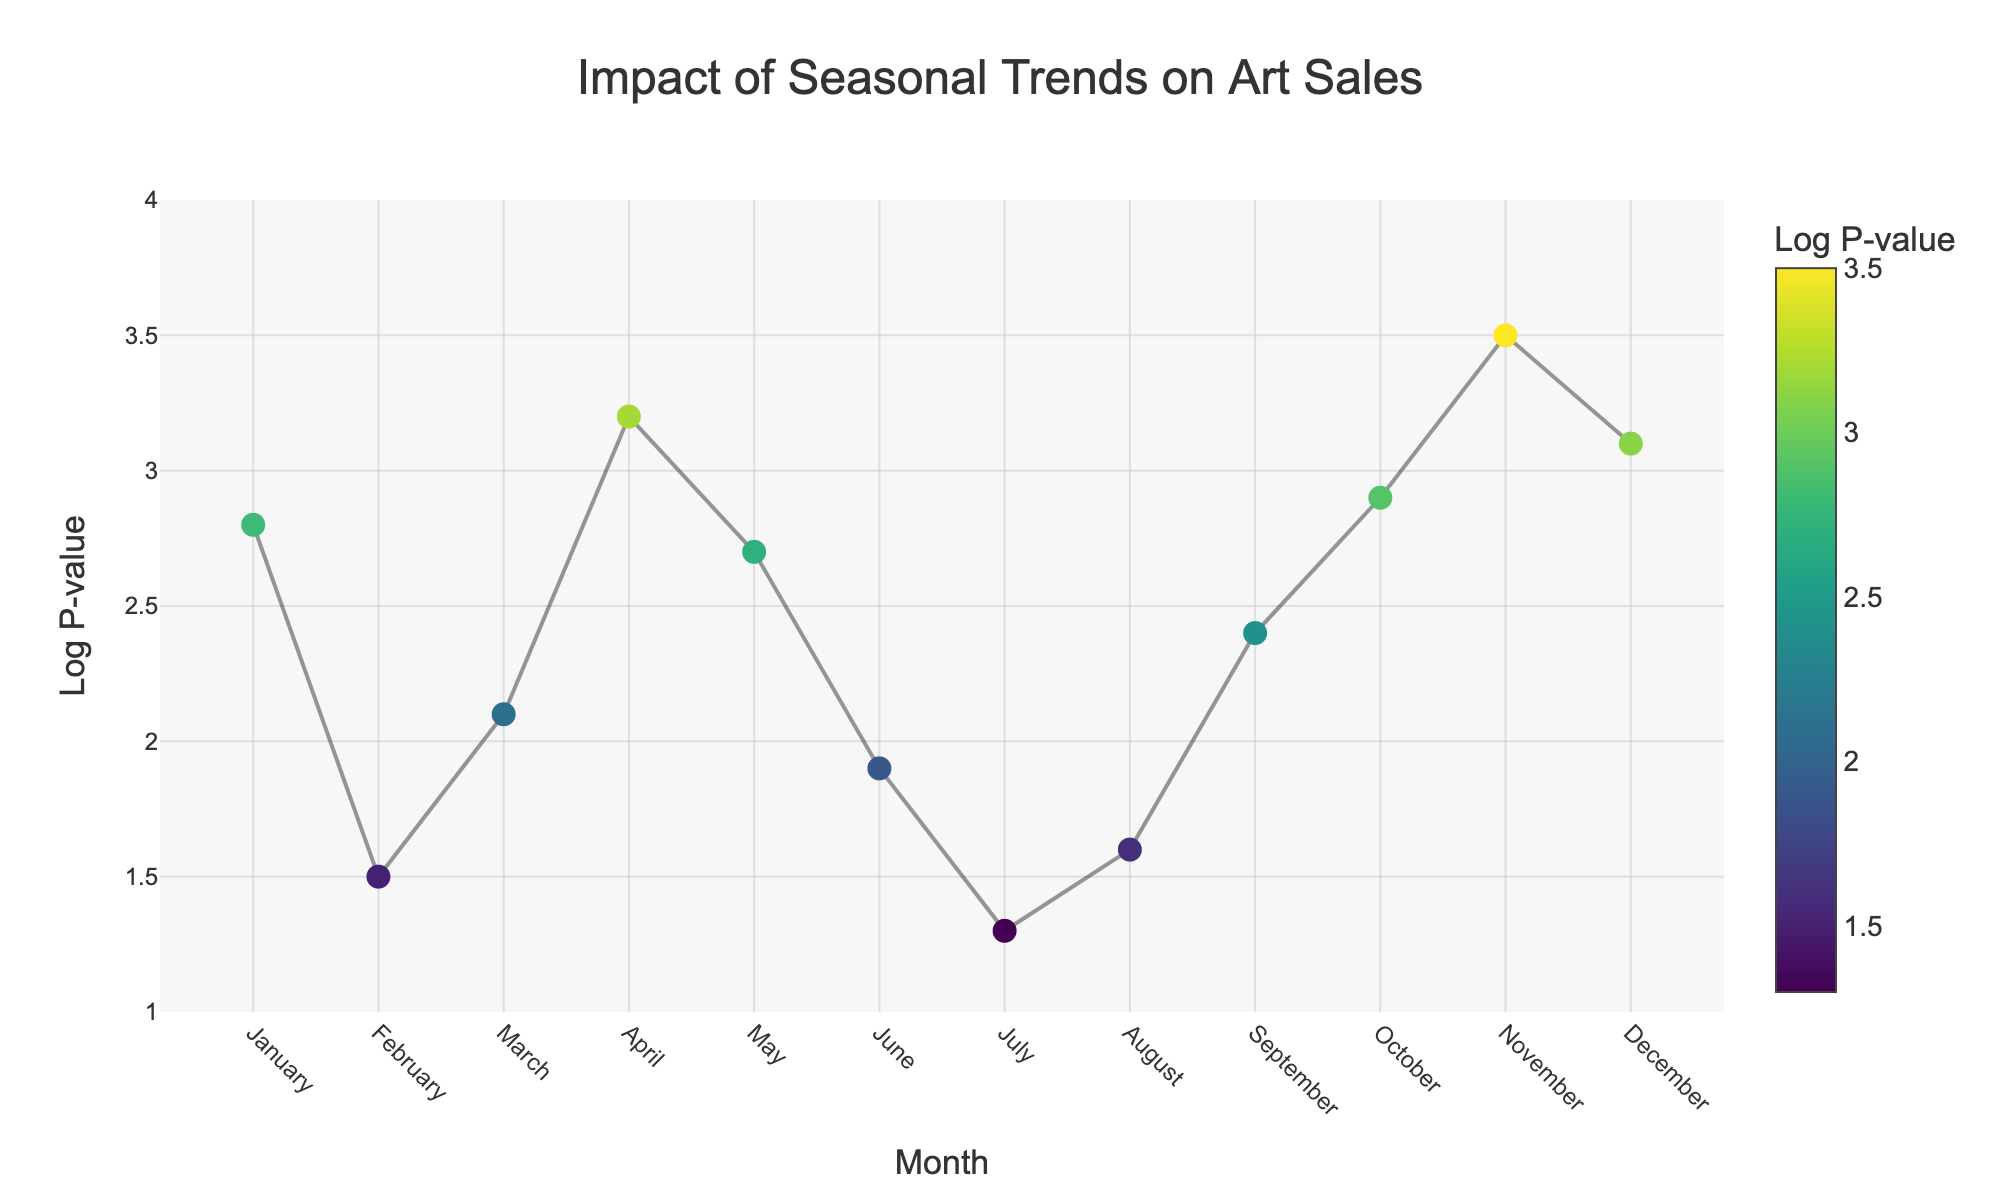What is the title of the figure? The title is displayed at the top center of the figure. It provides an overarching description of what the plot is about.
Answer: Impact of Seasonal Trends on Art Sales Which month has the highest Log P-value? To find the highest Log P-value, observe the y-axis values and see which data point reaches the highest value. November has the highest Log P-value with a value of 3.5.
Answer: November What is the Log P-value for Digital Art in April? Locate April on the x-axis and check the Log P-value associated with Digital Art. The marker for Digital Art corresponds to a Log P-value of 3.2.
Answer: 3.2 Which month shows the least impact on art sales? The least impact is indicated by the lowest Log P-value. July shows the least impact with a Log P-value of 1.3.
Answer: July Compare the Log P-values of Paintings in January and Mixed Media in May. Which one is higher? Identify the Log P-values for Paintings in January (2.8) and Mixed Media in May (2.7). Comparing these, Paintings in January have a higher Log P-value.
Answer: Paintings in January How many art categories have a Log P-value of 3.0 or higher? Count the number of categories where the Log P-value meets or exceeds 3.0. The categories are April, October, November, and December (Digital Art, Installations, Jewelry, Glass Art), totaling four categories.
Answer: 4 What is the difference in Log P-values between Sculptures in February and Prints in June? Identify the Log P-values for Sculptures in February (1.5) and Prints in June (1.9), then subtract the smaller value from the larger value. The difference is 1.9 - 1.5 = 0.4.
Answer: 0.4 During which month do Installations show their highest impact on art sales? Look at the Log P-value for Installations and identify the corresponding month. The highest Log P-value for Installations is in October with a value of 2.9.
Answer: October Are there any months where the Log P-values are identical? If yes, which months and what is the value? Scan through the figure to check if any two months share the same Log P-value. No two months have identical Log P-values; each month's value is unique.
Answer: No, there are no identical Log P-values In which months does the Log P-value exceed 3.0, and what categories are associated with those values? Identify the months where the Log P-value is above 3.0 and note the associated categories. The months are April (Digital Art), October (Installations), November (Jewelry), and December (Glass Art).
Answer: April, October, November, December (Digital Art, Installations, Jewelry, Glass Art) 